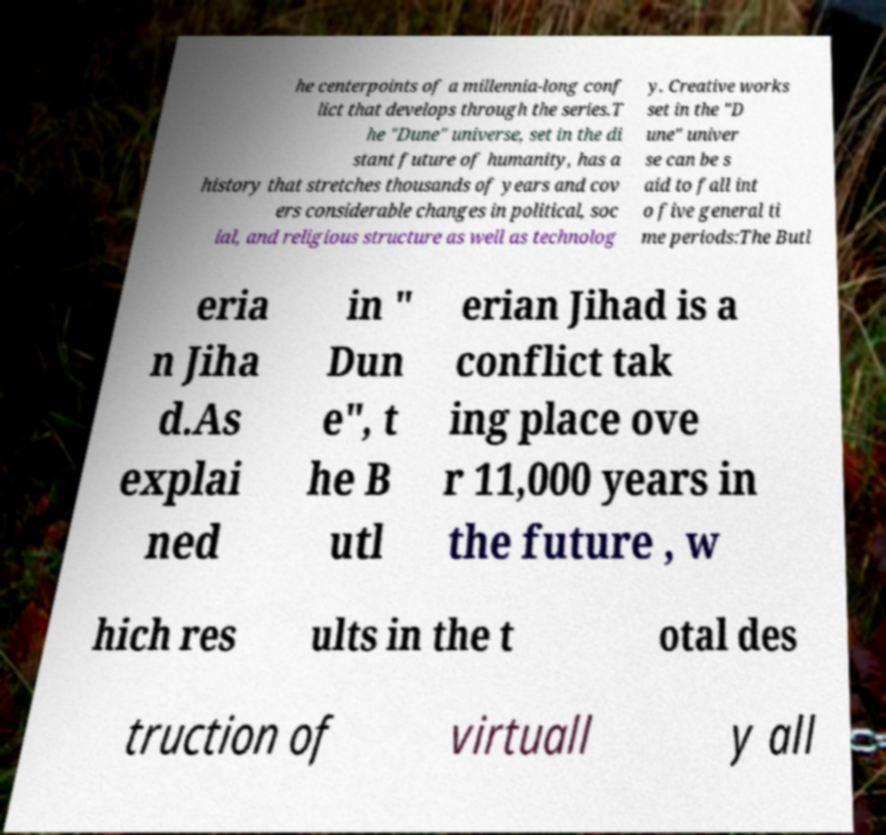There's text embedded in this image that I need extracted. Can you transcribe it verbatim? he centerpoints of a millennia-long conf lict that develops through the series.T he "Dune" universe, set in the di stant future of humanity, has a history that stretches thousands of years and cov ers considerable changes in political, soc ial, and religious structure as well as technolog y. Creative works set in the "D une" univer se can be s aid to fall int o five general ti me periods:The Butl eria n Jiha d.As explai ned in " Dun e", t he B utl erian Jihad is a conflict tak ing place ove r 11,000 years in the future , w hich res ults in the t otal des truction of virtuall y all 